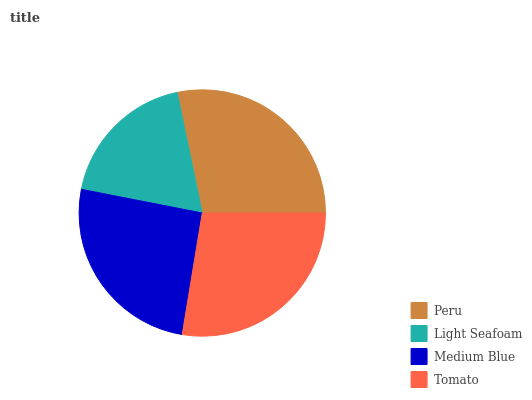Is Light Seafoam the minimum?
Answer yes or no. Yes. Is Peru the maximum?
Answer yes or no. Yes. Is Medium Blue the minimum?
Answer yes or no. No. Is Medium Blue the maximum?
Answer yes or no. No. Is Medium Blue greater than Light Seafoam?
Answer yes or no. Yes. Is Light Seafoam less than Medium Blue?
Answer yes or no. Yes. Is Light Seafoam greater than Medium Blue?
Answer yes or no. No. Is Medium Blue less than Light Seafoam?
Answer yes or no. No. Is Tomato the high median?
Answer yes or no. Yes. Is Medium Blue the low median?
Answer yes or no. Yes. Is Light Seafoam the high median?
Answer yes or no. No. Is Peru the low median?
Answer yes or no. No. 